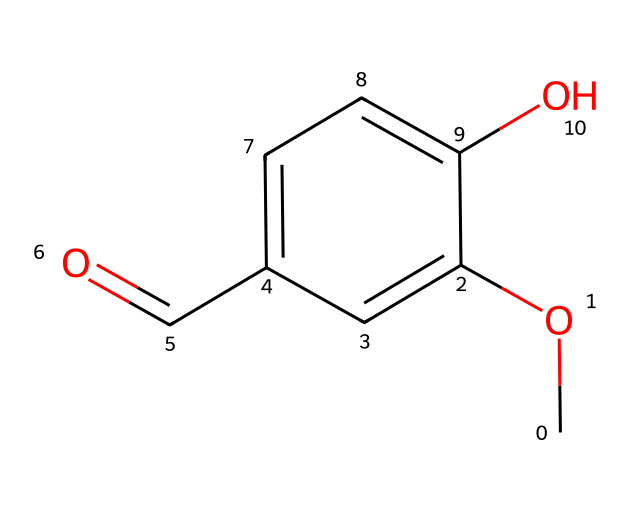What is the molecular formula of vanillin? The SMILES representation indicates the presence of carbon (C), hydrogen (H), and oxygen (O) atoms. Counting the number of C, H, and O, we find there are 8 carbon atoms, 8 hydrogen atoms, and 3 oxygen atoms, giving the molecular formula C8H8O3.
Answer: C8H8O3 How many hydroxyl (–OH) groups are present in this molecule? Examining the structure reveals one hydroxyl group (–OH) attached to the carbon ring. This is indicated by the presence of the oxygen atom connected to hydrogen, clearly shown in the chemical structure.
Answer: 1 What type of functional group is found at the end of the molecule? The structure shows a –CHO group, which is characteristic of an aldehyde functional group. In the chemical layout, it's localized on the benzene ring at the first position to the right.
Answer: aldehyde How many rings are present in the structure of vanillin? The structure contains one aromatic ring, identified by the six carbon atoms forming a hexagonal structure with alternating double bonds. This is typical of aromatic compounds.
Answer: 1 What is the effect of the –OCH3 group on the flavor of vanillin? The –OCH3 (methoxy) group enhances the aromatic property of vanillin, contributing to its sweet, vanilla-like flavor. In aromatic compounds, such substituents influence the smell and taste profiles significantly.
Answer: Sweet flavor Is vanillin a saturated or unsaturated compound? The presence of double bonds in the benzene ring indicates that vanillin is an unsaturated compound. This can be deduced from the alternating double bonds typical of aromatic structures.
Answer: Unsaturated 